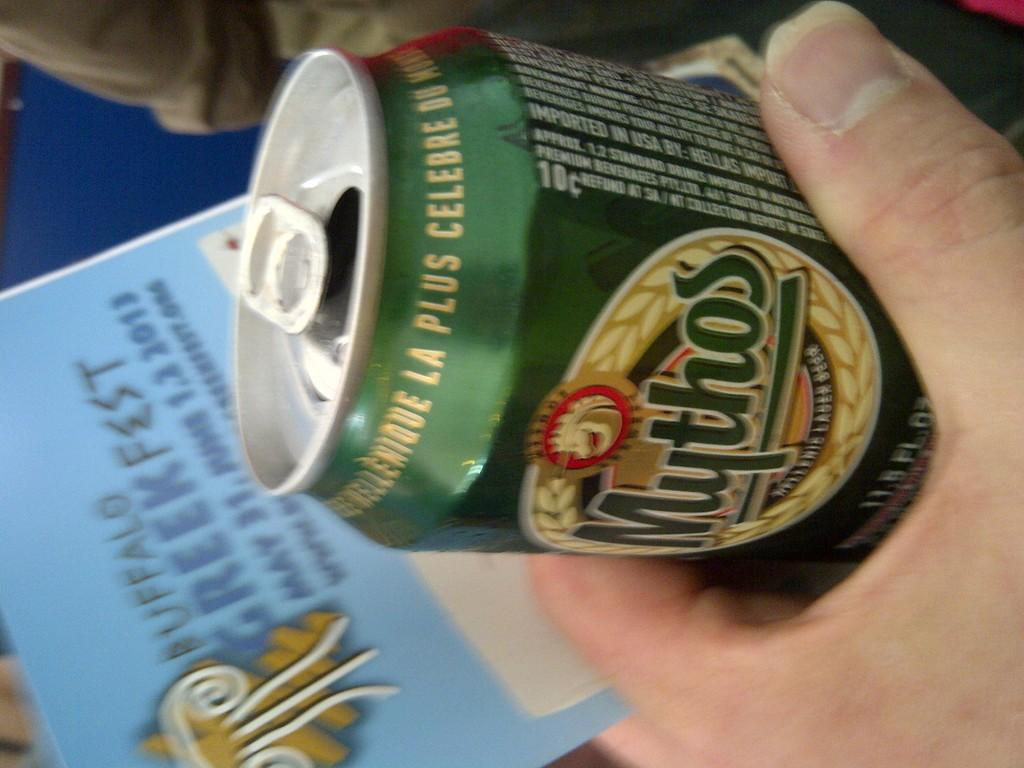<image>
Offer a succinct explanation of the picture presented. A green can has the Mythos logo on it. 